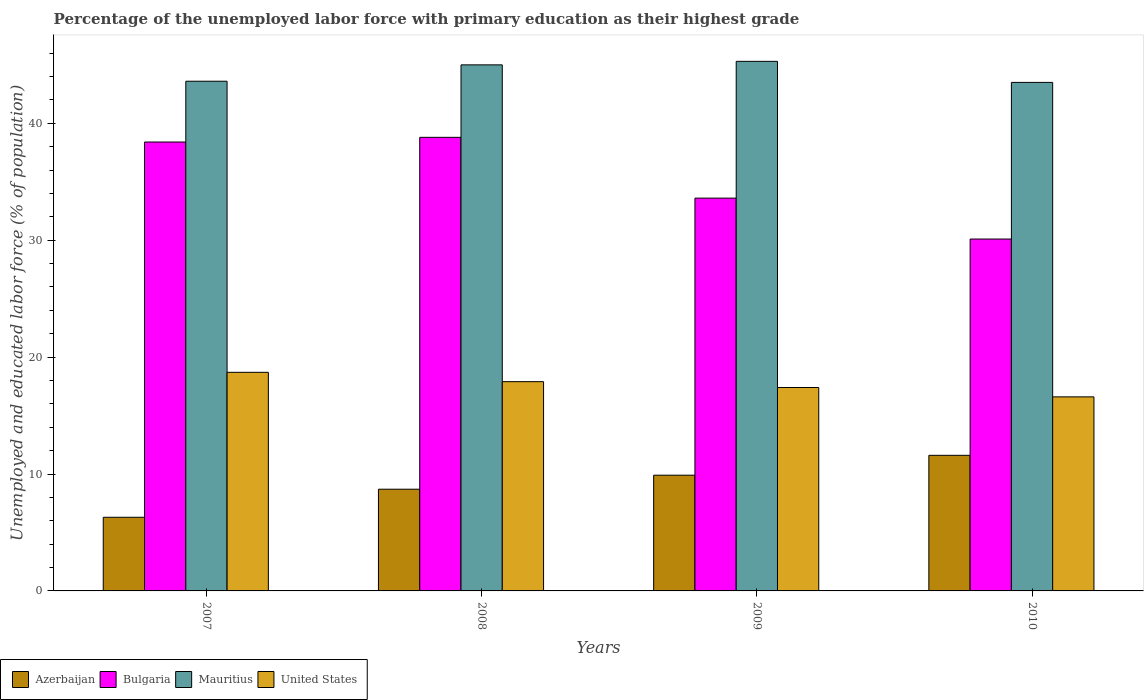How many different coloured bars are there?
Make the answer very short. 4. How many groups of bars are there?
Your response must be concise. 4. Are the number of bars per tick equal to the number of legend labels?
Ensure brevity in your answer.  Yes. Are the number of bars on each tick of the X-axis equal?
Your answer should be very brief. Yes. How many bars are there on the 4th tick from the right?
Ensure brevity in your answer.  4. What is the label of the 2nd group of bars from the left?
Ensure brevity in your answer.  2008. In how many cases, is the number of bars for a given year not equal to the number of legend labels?
Offer a very short reply. 0. What is the percentage of the unemployed labor force with primary education in Bulgaria in 2010?
Provide a succinct answer. 30.1. Across all years, what is the maximum percentage of the unemployed labor force with primary education in Bulgaria?
Provide a short and direct response. 38.8. Across all years, what is the minimum percentage of the unemployed labor force with primary education in United States?
Provide a succinct answer. 16.6. In which year was the percentage of the unemployed labor force with primary education in United States minimum?
Your answer should be very brief. 2010. What is the total percentage of the unemployed labor force with primary education in United States in the graph?
Give a very brief answer. 70.6. What is the difference between the percentage of the unemployed labor force with primary education in Mauritius in 2008 and that in 2009?
Offer a very short reply. -0.3. What is the difference between the percentage of the unemployed labor force with primary education in Bulgaria in 2007 and the percentage of the unemployed labor force with primary education in Mauritius in 2010?
Make the answer very short. -5.1. What is the average percentage of the unemployed labor force with primary education in Azerbaijan per year?
Your answer should be compact. 9.12. In the year 2010, what is the difference between the percentage of the unemployed labor force with primary education in United States and percentage of the unemployed labor force with primary education in Mauritius?
Keep it short and to the point. -26.9. In how many years, is the percentage of the unemployed labor force with primary education in Mauritius greater than 42 %?
Provide a succinct answer. 4. What is the ratio of the percentage of the unemployed labor force with primary education in Azerbaijan in 2007 to that in 2008?
Your response must be concise. 0.72. Is the percentage of the unemployed labor force with primary education in United States in 2008 less than that in 2009?
Your answer should be very brief. No. Is the difference between the percentage of the unemployed labor force with primary education in United States in 2008 and 2010 greater than the difference between the percentage of the unemployed labor force with primary education in Mauritius in 2008 and 2010?
Make the answer very short. No. What is the difference between the highest and the second highest percentage of the unemployed labor force with primary education in Mauritius?
Your response must be concise. 0.3. What is the difference between the highest and the lowest percentage of the unemployed labor force with primary education in United States?
Provide a short and direct response. 2.1. In how many years, is the percentage of the unemployed labor force with primary education in Bulgaria greater than the average percentage of the unemployed labor force with primary education in Bulgaria taken over all years?
Your answer should be very brief. 2. Is the sum of the percentage of the unemployed labor force with primary education in Mauritius in 2008 and 2010 greater than the maximum percentage of the unemployed labor force with primary education in Bulgaria across all years?
Make the answer very short. Yes. What does the 2nd bar from the left in 2009 represents?
Provide a succinct answer. Bulgaria. What does the 3rd bar from the right in 2009 represents?
Keep it short and to the point. Bulgaria. What is the difference between two consecutive major ticks on the Y-axis?
Ensure brevity in your answer.  10. Does the graph contain grids?
Make the answer very short. No. How are the legend labels stacked?
Offer a terse response. Horizontal. What is the title of the graph?
Your answer should be very brief. Percentage of the unemployed labor force with primary education as their highest grade. Does "Ghana" appear as one of the legend labels in the graph?
Offer a very short reply. No. What is the label or title of the X-axis?
Make the answer very short. Years. What is the label or title of the Y-axis?
Provide a succinct answer. Unemployed and educated labor force (% of population). What is the Unemployed and educated labor force (% of population) of Azerbaijan in 2007?
Your answer should be compact. 6.3. What is the Unemployed and educated labor force (% of population) in Bulgaria in 2007?
Your response must be concise. 38.4. What is the Unemployed and educated labor force (% of population) in Mauritius in 2007?
Your answer should be compact. 43.6. What is the Unemployed and educated labor force (% of population) in United States in 2007?
Keep it short and to the point. 18.7. What is the Unemployed and educated labor force (% of population) of Azerbaijan in 2008?
Your answer should be very brief. 8.7. What is the Unemployed and educated labor force (% of population) in Bulgaria in 2008?
Provide a succinct answer. 38.8. What is the Unemployed and educated labor force (% of population) in Mauritius in 2008?
Keep it short and to the point. 45. What is the Unemployed and educated labor force (% of population) of United States in 2008?
Offer a very short reply. 17.9. What is the Unemployed and educated labor force (% of population) of Azerbaijan in 2009?
Give a very brief answer. 9.9. What is the Unemployed and educated labor force (% of population) of Bulgaria in 2009?
Your response must be concise. 33.6. What is the Unemployed and educated labor force (% of population) of Mauritius in 2009?
Make the answer very short. 45.3. What is the Unemployed and educated labor force (% of population) in United States in 2009?
Offer a terse response. 17.4. What is the Unemployed and educated labor force (% of population) of Azerbaijan in 2010?
Make the answer very short. 11.6. What is the Unemployed and educated labor force (% of population) of Bulgaria in 2010?
Ensure brevity in your answer.  30.1. What is the Unemployed and educated labor force (% of population) in Mauritius in 2010?
Offer a terse response. 43.5. What is the Unemployed and educated labor force (% of population) in United States in 2010?
Provide a short and direct response. 16.6. Across all years, what is the maximum Unemployed and educated labor force (% of population) of Azerbaijan?
Provide a short and direct response. 11.6. Across all years, what is the maximum Unemployed and educated labor force (% of population) of Bulgaria?
Ensure brevity in your answer.  38.8. Across all years, what is the maximum Unemployed and educated labor force (% of population) in Mauritius?
Make the answer very short. 45.3. Across all years, what is the maximum Unemployed and educated labor force (% of population) in United States?
Offer a very short reply. 18.7. Across all years, what is the minimum Unemployed and educated labor force (% of population) of Azerbaijan?
Your answer should be compact. 6.3. Across all years, what is the minimum Unemployed and educated labor force (% of population) of Bulgaria?
Your response must be concise. 30.1. Across all years, what is the minimum Unemployed and educated labor force (% of population) in Mauritius?
Give a very brief answer. 43.5. Across all years, what is the minimum Unemployed and educated labor force (% of population) in United States?
Offer a very short reply. 16.6. What is the total Unemployed and educated labor force (% of population) of Azerbaijan in the graph?
Ensure brevity in your answer.  36.5. What is the total Unemployed and educated labor force (% of population) in Bulgaria in the graph?
Provide a short and direct response. 140.9. What is the total Unemployed and educated labor force (% of population) of Mauritius in the graph?
Offer a terse response. 177.4. What is the total Unemployed and educated labor force (% of population) in United States in the graph?
Give a very brief answer. 70.6. What is the difference between the Unemployed and educated labor force (% of population) of Azerbaijan in 2007 and that in 2008?
Give a very brief answer. -2.4. What is the difference between the Unemployed and educated labor force (% of population) of Bulgaria in 2007 and that in 2008?
Offer a very short reply. -0.4. What is the difference between the Unemployed and educated labor force (% of population) of Mauritius in 2007 and that in 2008?
Provide a short and direct response. -1.4. What is the difference between the Unemployed and educated labor force (% of population) of United States in 2007 and that in 2008?
Keep it short and to the point. 0.8. What is the difference between the Unemployed and educated labor force (% of population) of Bulgaria in 2007 and that in 2009?
Your answer should be compact. 4.8. What is the difference between the Unemployed and educated labor force (% of population) in United States in 2007 and that in 2009?
Your answer should be compact. 1.3. What is the difference between the Unemployed and educated labor force (% of population) of Azerbaijan in 2007 and that in 2010?
Your response must be concise. -5.3. What is the difference between the Unemployed and educated labor force (% of population) of United States in 2007 and that in 2010?
Offer a terse response. 2.1. What is the difference between the Unemployed and educated labor force (% of population) of Azerbaijan in 2008 and that in 2009?
Ensure brevity in your answer.  -1.2. What is the difference between the Unemployed and educated labor force (% of population) in Mauritius in 2008 and that in 2009?
Your response must be concise. -0.3. What is the difference between the Unemployed and educated labor force (% of population) in Azerbaijan in 2008 and that in 2010?
Your response must be concise. -2.9. What is the difference between the Unemployed and educated labor force (% of population) of Bulgaria in 2008 and that in 2010?
Give a very brief answer. 8.7. What is the difference between the Unemployed and educated labor force (% of population) of Mauritius in 2008 and that in 2010?
Your response must be concise. 1.5. What is the difference between the Unemployed and educated labor force (% of population) of Bulgaria in 2009 and that in 2010?
Ensure brevity in your answer.  3.5. What is the difference between the Unemployed and educated labor force (% of population) of Mauritius in 2009 and that in 2010?
Keep it short and to the point. 1.8. What is the difference between the Unemployed and educated labor force (% of population) in Azerbaijan in 2007 and the Unemployed and educated labor force (% of population) in Bulgaria in 2008?
Your response must be concise. -32.5. What is the difference between the Unemployed and educated labor force (% of population) of Azerbaijan in 2007 and the Unemployed and educated labor force (% of population) of Mauritius in 2008?
Your answer should be very brief. -38.7. What is the difference between the Unemployed and educated labor force (% of population) of Bulgaria in 2007 and the Unemployed and educated labor force (% of population) of Mauritius in 2008?
Offer a very short reply. -6.6. What is the difference between the Unemployed and educated labor force (% of population) in Bulgaria in 2007 and the Unemployed and educated labor force (% of population) in United States in 2008?
Your response must be concise. 20.5. What is the difference between the Unemployed and educated labor force (% of population) in Mauritius in 2007 and the Unemployed and educated labor force (% of population) in United States in 2008?
Offer a terse response. 25.7. What is the difference between the Unemployed and educated labor force (% of population) in Azerbaijan in 2007 and the Unemployed and educated labor force (% of population) in Bulgaria in 2009?
Give a very brief answer. -27.3. What is the difference between the Unemployed and educated labor force (% of population) of Azerbaijan in 2007 and the Unemployed and educated labor force (% of population) of Mauritius in 2009?
Make the answer very short. -39. What is the difference between the Unemployed and educated labor force (% of population) in Azerbaijan in 2007 and the Unemployed and educated labor force (% of population) in United States in 2009?
Give a very brief answer. -11.1. What is the difference between the Unemployed and educated labor force (% of population) of Bulgaria in 2007 and the Unemployed and educated labor force (% of population) of Mauritius in 2009?
Offer a very short reply. -6.9. What is the difference between the Unemployed and educated labor force (% of population) of Mauritius in 2007 and the Unemployed and educated labor force (% of population) of United States in 2009?
Make the answer very short. 26.2. What is the difference between the Unemployed and educated labor force (% of population) in Azerbaijan in 2007 and the Unemployed and educated labor force (% of population) in Bulgaria in 2010?
Make the answer very short. -23.8. What is the difference between the Unemployed and educated labor force (% of population) in Azerbaijan in 2007 and the Unemployed and educated labor force (% of population) in Mauritius in 2010?
Offer a very short reply. -37.2. What is the difference between the Unemployed and educated labor force (% of population) in Azerbaijan in 2007 and the Unemployed and educated labor force (% of population) in United States in 2010?
Your answer should be compact. -10.3. What is the difference between the Unemployed and educated labor force (% of population) in Bulgaria in 2007 and the Unemployed and educated labor force (% of population) in United States in 2010?
Your response must be concise. 21.8. What is the difference between the Unemployed and educated labor force (% of population) in Mauritius in 2007 and the Unemployed and educated labor force (% of population) in United States in 2010?
Keep it short and to the point. 27. What is the difference between the Unemployed and educated labor force (% of population) of Azerbaijan in 2008 and the Unemployed and educated labor force (% of population) of Bulgaria in 2009?
Provide a short and direct response. -24.9. What is the difference between the Unemployed and educated labor force (% of population) of Azerbaijan in 2008 and the Unemployed and educated labor force (% of population) of Mauritius in 2009?
Give a very brief answer. -36.6. What is the difference between the Unemployed and educated labor force (% of population) of Bulgaria in 2008 and the Unemployed and educated labor force (% of population) of United States in 2009?
Offer a terse response. 21.4. What is the difference between the Unemployed and educated labor force (% of population) in Mauritius in 2008 and the Unemployed and educated labor force (% of population) in United States in 2009?
Ensure brevity in your answer.  27.6. What is the difference between the Unemployed and educated labor force (% of population) of Azerbaijan in 2008 and the Unemployed and educated labor force (% of population) of Bulgaria in 2010?
Give a very brief answer. -21.4. What is the difference between the Unemployed and educated labor force (% of population) in Azerbaijan in 2008 and the Unemployed and educated labor force (% of population) in Mauritius in 2010?
Your response must be concise. -34.8. What is the difference between the Unemployed and educated labor force (% of population) in Azerbaijan in 2008 and the Unemployed and educated labor force (% of population) in United States in 2010?
Make the answer very short. -7.9. What is the difference between the Unemployed and educated labor force (% of population) of Bulgaria in 2008 and the Unemployed and educated labor force (% of population) of Mauritius in 2010?
Provide a succinct answer. -4.7. What is the difference between the Unemployed and educated labor force (% of population) of Mauritius in 2008 and the Unemployed and educated labor force (% of population) of United States in 2010?
Offer a terse response. 28.4. What is the difference between the Unemployed and educated labor force (% of population) in Azerbaijan in 2009 and the Unemployed and educated labor force (% of population) in Bulgaria in 2010?
Your response must be concise. -20.2. What is the difference between the Unemployed and educated labor force (% of population) in Azerbaijan in 2009 and the Unemployed and educated labor force (% of population) in Mauritius in 2010?
Your answer should be compact. -33.6. What is the difference between the Unemployed and educated labor force (% of population) of Bulgaria in 2009 and the Unemployed and educated labor force (% of population) of Mauritius in 2010?
Your answer should be very brief. -9.9. What is the difference between the Unemployed and educated labor force (% of population) of Mauritius in 2009 and the Unemployed and educated labor force (% of population) of United States in 2010?
Offer a terse response. 28.7. What is the average Unemployed and educated labor force (% of population) in Azerbaijan per year?
Provide a succinct answer. 9.12. What is the average Unemployed and educated labor force (% of population) of Bulgaria per year?
Your response must be concise. 35.23. What is the average Unemployed and educated labor force (% of population) in Mauritius per year?
Offer a very short reply. 44.35. What is the average Unemployed and educated labor force (% of population) in United States per year?
Ensure brevity in your answer.  17.65. In the year 2007, what is the difference between the Unemployed and educated labor force (% of population) in Azerbaijan and Unemployed and educated labor force (% of population) in Bulgaria?
Make the answer very short. -32.1. In the year 2007, what is the difference between the Unemployed and educated labor force (% of population) in Azerbaijan and Unemployed and educated labor force (% of population) in Mauritius?
Make the answer very short. -37.3. In the year 2007, what is the difference between the Unemployed and educated labor force (% of population) of Azerbaijan and Unemployed and educated labor force (% of population) of United States?
Provide a succinct answer. -12.4. In the year 2007, what is the difference between the Unemployed and educated labor force (% of population) of Bulgaria and Unemployed and educated labor force (% of population) of Mauritius?
Offer a terse response. -5.2. In the year 2007, what is the difference between the Unemployed and educated labor force (% of population) in Mauritius and Unemployed and educated labor force (% of population) in United States?
Provide a short and direct response. 24.9. In the year 2008, what is the difference between the Unemployed and educated labor force (% of population) of Azerbaijan and Unemployed and educated labor force (% of population) of Bulgaria?
Give a very brief answer. -30.1. In the year 2008, what is the difference between the Unemployed and educated labor force (% of population) in Azerbaijan and Unemployed and educated labor force (% of population) in Mauritius?
Provide a short and direct response. -36.3. In the year 2008, what is the difference between the Unemployed and educated labor force (% of population) of Azerbaijan and Unemployed and educated labor force (% of population) of United States?
Ensure brevity in your answer.  -9.2. In the year 2008, what is the difference between the Unemployed and educated labor force (% of population) in Bulgaria and Unemployed and educated labor force (% of population) in Mauritius?
Give a very brief answer. -6.2. In the year 2008, what is the difference between the Unemployed and educated labor force (% of population) of Bulgaria and Unemployed and educated labor force (% of population) of United States?
Your answer should be very brief. 20.9. In the year 2008, what is the difference between the Unemployed and educated labor force (% of population) of Mauritius and Unemployed and educated labor force (% of population) of United States?
Keep it short and to the point. 27.1. In the year 2009, what is the difference between the Unemployed and educated labor force (% of population) in Azerbaijan and Unemployed and educated labor force (% of population) in Bulgaria?
Provide a succinct answer. -23.7. In the year 2009, what is the difference between the Unemployed and educated labor force (% of population) in Azerbaijan and Unemployed and educated labor force (% of population) in Mauritius?
Give a very brief answer. -35.4. In the year 2009, what is the difference between the Unemployed and educated labor force (% of population) of Bulgaria and Unemployed and educated labor force (% of population) of Mauritius?
Make the answer very short. -11.7. In the year 2009, what is the difference between the Unemployed and educated labor force (% of population) in Bulgaria and Unemployed and educated labor force (% of population) in United States?
Provide a succinct answer. 16.2. In the year 2009, what is the difference between the Unemployed and educated labor force (% of population) of Mauritius and Unemployed and educated labor force (% of population) of United States?
Provide a succinct answer. 27.9. In the year 2010, what is the difference between the Unemployed and educated labor force (% of population) of Azerbaijan and Unemployed and educated labor force (% of population) of Bulgaria?
Your answer should be very brief. -18.5. In the year 2010, what is the difference between the Unemployed and educated labor force (% of population) in Azerbaijan and Unemployed and educated labor force (% of population) in Mauritius?
Keep it short and to the point. -31.9. In the year 2010, what is the difference between the Unemployed and educated labor force (% of population) of Bulgaria and Unemployed and educated labor force (% of population) of United States?
Make the answer very short. 13.5. In the year 2010, what is the difference between the Unemployed and educated labor force (% of population) of Mauritius and Unemployed and educated labor force (% of population) of United States?
Your answer should be compact. 26.9. What is the ratio of the Unemployed and educated labor force (% of population) of Azerbaijan in 2007 to that in 2008?
Make the answer very short. 0.72. What is the ratio of the Unemployed and educated labor force (% of population) in Mauritius in 2007 to that in 2008?
Provide a succinct answer. 0.97. What is the ratio of the Unemployed and educated labor force (% of population) of United States in 2007 to that in 2008?
Make the answer very short. 1.04. What is the ratio of the Unemployed and educated labor force (% of population) of Azerbaijan in 2007 to that in 2009?
Make the answer very short. 0.64. What is the ratio of the Unemployed and educated labor force (% of population) of Bulgaria in 2007 to that in 2009?
Give a very brief answer. 1.14. What is the ratio of the Unemployed and educated labor force (% of population) in Mauritius in 2007 to that in 2009?
Offer a very short reply. 0.96. What is the ratio of the Unemployed and educated labor force (% of population) in United States in 2007 to that in 2009?
Your answer should be very brief. 1.07. What is the ratio of the Unemployed and educated labor force (% of population) in Azerbaijan in 2007 to that in 2010?
Give a very brief answer. 0.54. What is the ratio of the Unemployed and educated labor force (% of population) in Bulgaria in 2007 to that in 2010?
Offer a very short reply. 1.28. What is the ratio of the Unemployed and educated labor force (% of population) in United States in 2007 to that in 2010?
Keep it short and to the point. 1.13. What is the ratio of the Unemployed and educated labor force (% of population) of Azerbaijan in 2008 to that in 2009?
Provide a short and direct response. 0.88. What is the ratio of the Unemployed and educated labor force (% of population) in Bulgaria in 2008 to that in 2009?
Give a very brief answer. 1.15. What is the ratio of the Unemployed and educated labor force (% of population) of United States in 2008 to that in 2009?
Your response must be concise. 1.03. What is the ratio of the Unemployed and educated labor force (% of population) in Bulgaria in 2008 to that in 2010?
Your response must be concise. 1.29. What is the ratio of the Unemployed and educated labor force (% of population) of Mauritius in 2008 to that in 2010?
Your answer should be compact. 1.03. What is the ratio of the Unemployed and educated labor force (% of population) of United States in 2008 to that in 2010?
Make the answer very short. 1.08. What is the ratio of the Unemployed and educated labor force (% of population) of Azerbaijan in 2009 to that in 2010?
Offer a terse response. 0.85. What is the ratio of the Unemployed and educated labor force (% of population) in Bulgaria in 2009 to that in 2010?
Your answer should be very brief. 1.12. What is the ratio of the Unemployed and educated labor force (% of population) of Mauritius in 2009 to that in 2010?
Ensure brevity in your answer.  1.04. What is the ratio of the Unemployed and educated labor force (% of population) of United States in 2009 to that in 2010?
Offer a very short reply. 1.05. What is the difference between the highest and the second highest Unemployed and educated labor force (% of population) of United States?
Offer a terse response. 0.8. What is the difference between the highest and the lowest Unemployed and educated labor force (% of population) of United States?
Provide a short and direct response. 2.1. 